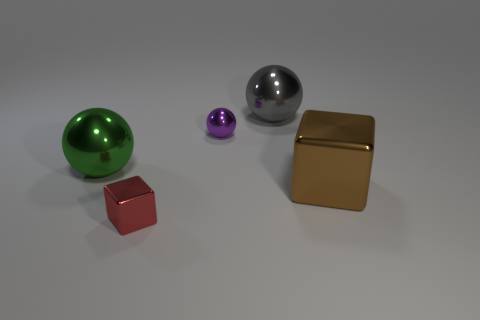What materials do the objects in the image seem to be made of? The objects appear to be made of various materials. The green and silver items look metallic with reflective surfaces, suggesting they could be steel or aluminum. The red item has a matte finish, resembling plastic or painted wood, while the gold item has a glossy surface that implies a metallic paint finish, perhaps gold-toned steel or brass. 